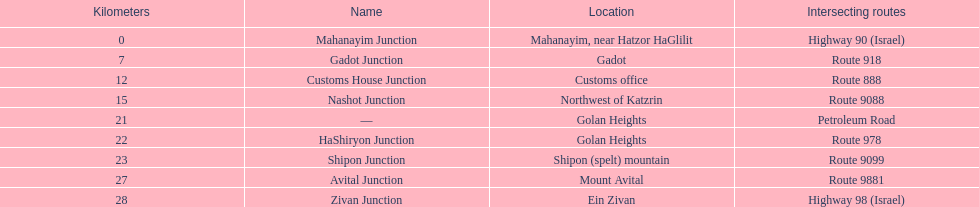Help me parse the entirety of this table. {'header': ['Kilometers', 'Name', 'Location', 'Intersecting routes'], 'rows': [['0', 'Mahanayim Junction', 'Mahanayim, near Hatzor HaGlilit', 'Highway 90 (Israel)'], ['7', 'Gadot Junction', 'Gadot', 'Route 918'], ['12', 'Customs House Junction', 'Customs office', 'Route 888'], ['15', 'Nashot Junction', 'Northwest of Katzrin', 'Route 9088'], ['21', '—', 'Golan Heights', 'Petroleum Road'], ['22', 'HaShiryon Junction', 'Golan Heights', 'Route 978'], ['23', 'Shipon Junction', 'Shipon (spelt) mountain', 'Route 9099'], ['27', 'Avital Junction', 'Mount Avital', 'Route 9881'], ['28', 'Zivan Junction', 'Ein Zivan', 'Highway 98 (Israel)']]} What is the total kilometers that separates the mahanayim junction and the shipon junction? 23. 